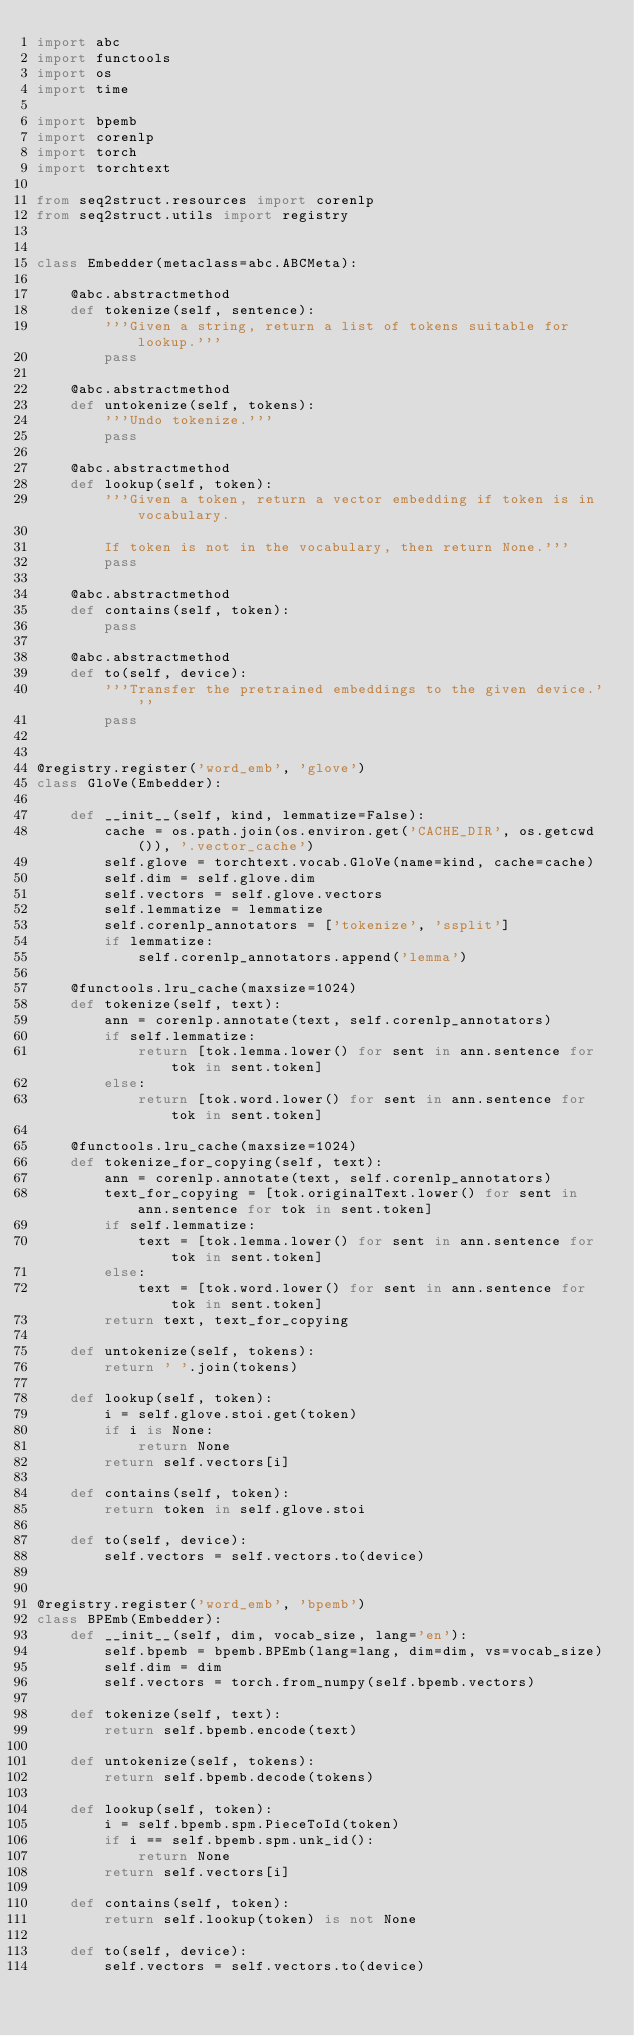<code> <loc_0><loc_0><loc_500><loc_500><_Python_>import abc
import functools
import os
import time

import bpemb
import corenlp
import torch
import torchtext

from seq2struct.resources import corenlp
from seq2struct.utils import registry


class Embedder(metaclass=abc.ABCMeta):

    @abc.abstractmethod
    def tokenize(self, sentence):
        '''Given a string, return a list of tokens suitable for lookup.'''
        pass

    @abc.abstractmethod
    def untokenize(self, tokens):
        '''Undo tokenize.'''
        pass

    @abc.abstractmethod
    def lookup(self, token):
        '''Given a token, return a vector embedding if token is in vocabulary.

        If token is not in the vocabulary, then return None.'''
        pass

    @abc.abstractmethod
    def contains(self, token):
        pass

    @abc.abstractmethod
    def to(self, device):
        '''Transfer the pretrained embeddings to the given device.'''
        pass


@registry.register('word_emb', 'glove')
class GloVe(Embedder):

    def __init__(self, kind, lemmatize=False):
        cache = os.path.join(os.environ.get('CACHE_DIR', os.getcwd()), '.vector_cache')
        self.glove = torchtext.vocab.GloVe(name=kind, cache=cache)
        self.dim = self.glove.dim
        self.vectors = self.glove.vectors
        self.lemmatize = lemmatize
        self.corenlp_annotators = ['tokenize', 'ssplit']
        if lemmatize:
            self.corenlp_annotators.append('lemma')

    @functools.lru_cache(maxsize=1024)
    def tokenize(self, text):
        ann = corenlp.annotate(text, self.corenlp_annotators)
        if self.lemmatize:
            return [tok.lemma.lower() for sent in ann.sentence for tok in sent.token]
        else:
            return [tok.word.lower() for sent in ann.sentence for tok in sent.token]
    
    @functools.lru_cache(maxsize=1024)
    def tokenize_for_copying(self, text):
        ann = corenlp.annotate(text, self.corenlp_annotators)
        text_for_copying = [tok.originalText.lower() for sent in ann.sentence for tok in sent.token]
        if self.lemmatize:
            text = [tok.lemma.lower() for sent in ann.sentence for tok in sent.token]
        else:
            text = [tok.word.lower() for sent in ann.sentence for tok in sent.token]
        return text, text_for_copying

    def untokenize(self, tokens):
        return ' '.join(tokens)

    def lookup(self, token):
        i = self.glove.stoi.get(token)
        if i is None:
            return None
        return self.vectors[i]

    def contains(self, token):
        return token in self.glove.stoi

    def to(self, device):
        self.vectors = self.vectors.to(device)


@registry.register('word_emb', 'bpemb')
class BPEmb(Embedder):
    def __init__(self, dim, vocab_size, lang='en'):
        self.bpemb = bpemb.BPEmb(lang=lang, dim=dim, vs=vocab_size)
        self.dim = dim
        self.vectors = torch.from_numpy(self.bpemb.vectors)

    def tokenize(self, text):
        return self.bpemb.encode(text)

    def untokenize(self, tokens):
        return self.bpemb.decode(tokens)

    def lookup(self, token):
        i = self.bpemb.spm.PieceToId(token)
        if i == self.bpemb.spm.unk_id():
            return None
        return self.vectors[i]

    def contains(self, token):
        return self.lookup(token) is not None

    def to(self, device):
        self.vectors = self.vectors.to(device)
</code> 